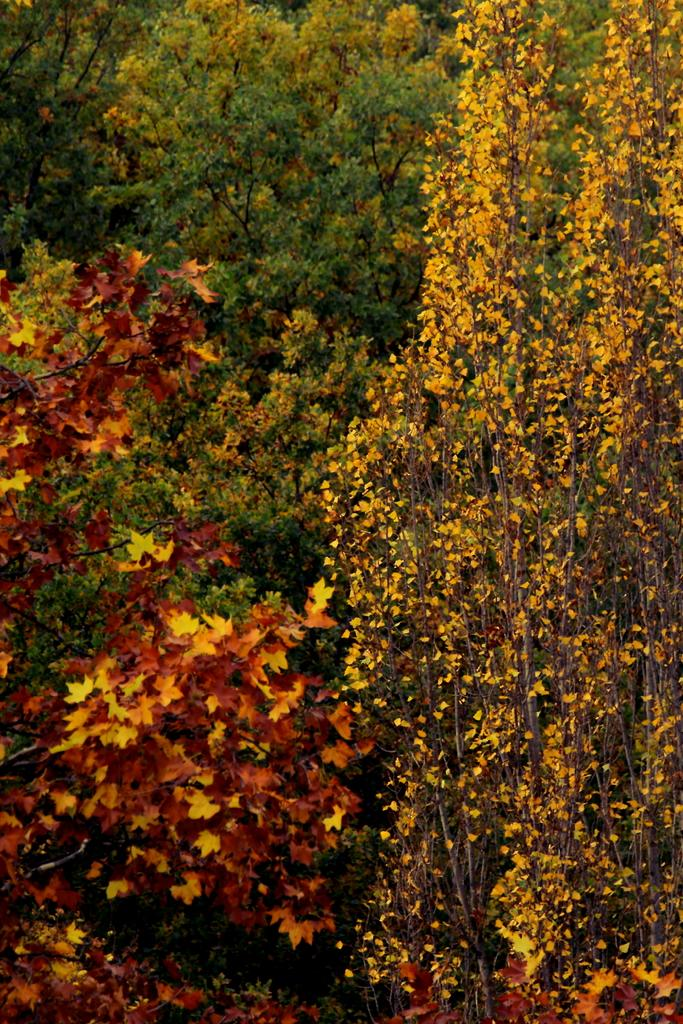What type of vegetation can be seen in the image? There are trees in the image. What is the condition of the leaves on the trees? The leaves on the trees have different colors. What type of treatment is being administered to the trees in the image? There is no indication in the image that any treatment is being administered to the trees. 